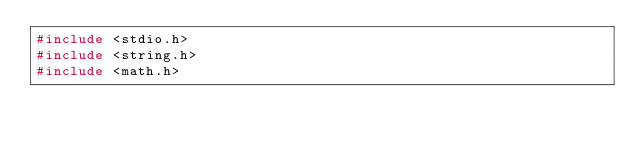Convert code to text. <code><loc_0><loc_0><loc_500><loc_500><_C_>#include <stdio.h>
#include <string.h>
#include <math.h></code> 